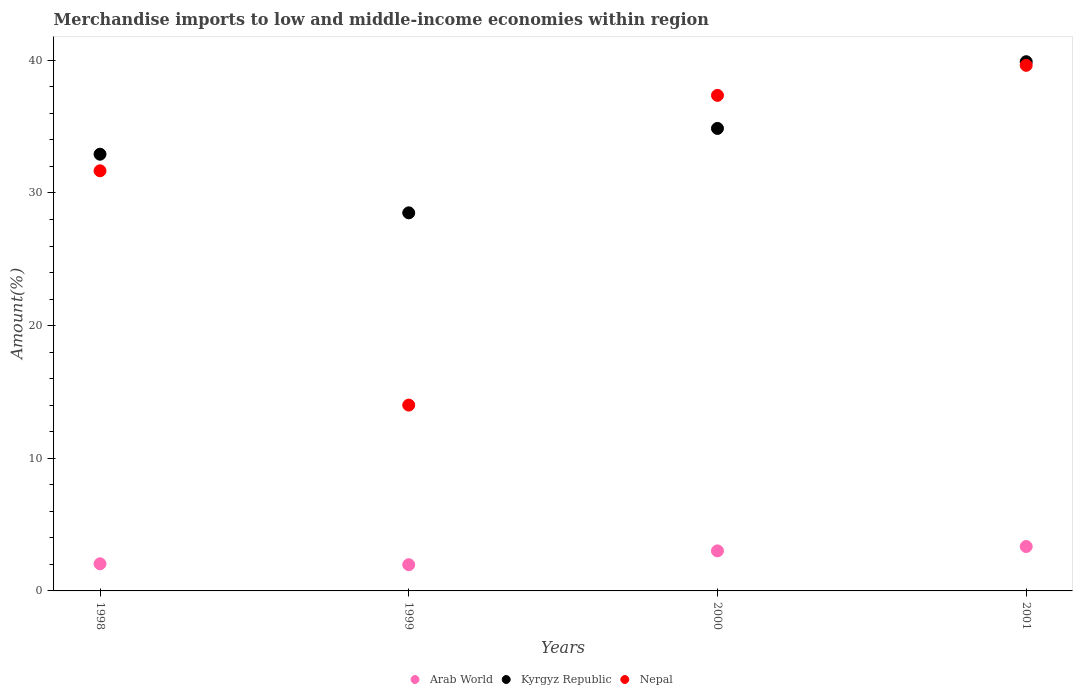How many different coloured dotlines are there?
Make the answer very short. 3. What is the percentage of amount earned from merchandise imports in Kyrgyz Republic in 2001?
Ensure brevity in your answer.  39.89. Across all years, what is the maximum percentage of amount earned from merchandise imports in Nepal?
Offer a terse response. 39.62. Across all years, what is the minimum percentage of amount earned from merchandise imports in Arab World?
Provide a short and direct response. 1.98. In which year was the percentage of amount earned from merchandise imports in Arab World maximum?
Make the answer very short. 2001. In which year was the percentage of amount earned from merchandise imports in Nepal minimum?
Ensure brevity in your answer.  1999. What is the total percentage of amount earned from merchandise imports in Arab World in the graph?
Your answer should be compact. 10.39. What is the difference between the percentage of amount earned from merchandise imports in Nepal in 1999 and that in 2001?
Give a very brief answer. -25.61. What is the difference between the percentage of amount earned from merchandise imports in Arab World in 1999 and the percentage of amount earned from merchandise imports in Kyrgyz Republic in 2000?
Your answer should be very brief. -32.89. What is the average percentage of amount earned from merchandise imports in Nepal per year?
Make the answer very short. 30.66. In the year 2000, what is the difference between the percentage of amount earned from merchandise imports in Kyrgyz Republic and percentage of amount earned from merchandise imports in Nepal?
Your answer should be very brief. -2.49. In how many years, is the percentage of amount earned from merchandise imports in Nepal greater than 2 %?
Your response must be concise. 4. What is the ratio of the percentage of amount earned from merchandise imports in Nepal in 1998 to that in 2001?
Keep it short and to the point. 0.8. What is the difference between the highest and the second highest percentage of amount earned from merchandise imports in Arab World?
Give a very brief answer. 0.33. What is the difference between the highest and the lowest percentage of amount earned from merchandise imports in Arab World?
Your response must be concise. 1.37. Is the sum of the percentage of amount earned from merchandise imports in Arab World in 1999 and 2000 greater than the maximum percentage of amount earned from merchandise imports in Kyrgyz Republic across all years?
Give a very brief answer. No. Does the percentage of amount earned from merchandise imports in Arab World monotonically increase over the years?
Provide a succinct answer. No. Is the percentage of amount earned from merchandise imports in Kyrgyz Republic strictly less than the percentage of amount earned from merchandise imports in Arab World over the years?
Your response must be concise. No. What is the difference between two consecutive major ticks on the Y-axis?
Keep it short and to the point. 10. Does the graph contain any zero values?
Ensure brevity in your answer.  No. Does the graph contain grids?
Make the answer very short. No. Where does the legend appear in the graph?
Offer a terse response. Bottom center. How are the legend labels stacked?
Offer a terse response. Horizontal. What is the title of the graph?
Make the answer very short. Merchandise imports to low and middle-income economies within region. Does "Latin America(all income levels)" appear as one of the legend labels in the graph?
Your response must be concise. No. What is the label or title of the Y-axis?
Keep it short and to the point. Amount(%). What is the Amount(%) of Arab World in 1998?
Keep it short and to the point. 2.05. What is the Amount(%) of Kyrgyz Republic in 1998?
Provide a succinct answer. 32.92. What is the Amount(%) of Nepal in 1998?
Your answer should be very brief. 31.67. What is the Amount(%) in Arab World in 1999?
Your answer should be very brief. 1.98. What is the Amount(%) in Kyrgyz Republic in 1999?
Provide a succinct answer. 28.5. What is the Amount(%) of Nepal in 1999?
Your answer should be compact. 14.01. What is the Amount(%) of Arab World in 2000?
Give a very brief answer. 3.02. What is the Amount(%) of Kyrgyz Republic in 2000?
Keep it short and to the point. 34.86. What is the Amount(%) in Nepal in 2000?
Give a very brief answer. 37.36. What is the Amount(%) in Arab World in 2001?
Your response must be concise. 3.35. What is the Amount(%) in Kyrgyz Republic in 2001?
Your answer should be very brief. 39.89. What is the Amount(%) in Nepal in 2001?
Offer a terse response. 39.62. Across all years, what is the maximum Amount(%) in Arab World?
Your response must be concise. 3.35. Across all years, what is the maximum Amount(%) in Kyrgyz Republic?
Make the answer very short. 39.89. Across all years, what is the maximum Amount(%) in Nepal?
Give a very brief answer. 39.62. Across all years, what is the minimum Amount(%) of Arab World?
Your answer should be very brief. 1.98. Across all years, what is the minimum Amount(%) in Kyrgyz Republic?
Your answer should be compact. 28.5. Across all years, what is the minimum Amount(%) of Nepal?
Ensure brevity in your answer.  14.01. What is the total Amount(%) of Arab World in the graph?
Your response must be concise. 10.39. What is the total Amount(%) in Kyrgyz Republic in the graph?
Provide a succinct answer. 136.18. What is the total Amount(%) of Nepal in the graph?
Provide a succinct answer. 122.66. What is the difference between the Amount(%) of Arab World in 1998 and that in 1999?
Your response must be concise. 0.07. What is the difference between the Amount(%) of Kyrgyz Republic in 1998 and that in 1999?
Offer a terse response. 4.42. What is the difference between the Amount(%) in Nepal in 1998 and that in 1999?
Your answer should be compact. 17.66. What is the difference between the Amount(%) of Arab World in 1998 and that in 2000?
Keep it short and to the point. -0.97. What is the difference between the Amount(%) of Kyrgyz Republic in 1998 and that in 2000?
Your response must be concise. -1.94. What is the difference between the Amount(%) in Nepal in 1998 and that in 2000?
Keep it short and to the point. -5.69. What is the difference between the Amount(%) in Arab World in 1998 and that in 2001?
Keep it short and to the point. -1.3. What is the difference between the Amount(%) of Kyrgyz Republic in 1998 and that in 2001?
Your answer should be very brief. -6.97. What is the difference between the Amount(%) of Nepal in 1998 and that in 2001?
Make the answer very short. -7.95. What is the difference between the Amount(%) of Arab World in 1999 and that in 2000?
Keep it short and to the point. -1.04. What is the difference between the Amount(%) of Kyrgyz Republic in 1999 and that in 2000?
Provide a succinct answer. -6.36. What is the difference between the Amount(%) of Nepal in 1999 and that in 2000?
Offer a terse response. -23.35. What is the difference between the Amount(%) in Arab World in 1999 and that in 2001?
Give a very brief answer. -1.37. What is the difference between the Amount(%) of Kyrgyz Republic in 1999 and that in 2001?
Make the answer very short. -11.39. What is the difference between the Amount(%) of Nepal in 1999 and that in 2001?
Give a very brief answer. -25.61. What is the difference between the Amount(%) in Arab World in 2000 and that in 2001?
Ensure brevity in your answer.  -0.33. What is the difference between the Amount(%) of Kyrgyz Republic in 2000 and that in 2001?
Keep it short and to the point. -5.03. What is the difference between the Amount(%) of Nepal in 2000 and that in 2001?
Ensure brevity in your answer.  -2.27. What is the difference between the Amount(%) of Arab World in 1998 and the Amount(%) of Kyrgyz Republic in 1999?
Your response must be concise. -26.46. What is the difference between the Amount(%) in Arab World in 1998 and the Amount(%) in Nepal in 1999?
Your answer should be compact. -11.96. What is the difference between the Amount(%) in Kyrgyz Republic in 1998 and the Amount(%) in Nepal in 1999?
Offer a terse response. 18.91. What is the difference between the Amount(%) of Arab World in 1998 and the Amount(%) of Kyrgyz Republic in 2000?
Make the answer very short. -32.82. What is the difference between the Amount(%) of Arab World in 1998 and the Amount(%) of Nepal in 2000?
Offer a terse response. -35.31. What is the difference between the Amount(%) in Kyrgyz Republic in 1998 and the Amount(%) in Nepal in 2000?
Your answer should be very brief. -4.43. What is the difference between the Amount(%) in Arab World in 1998 and the Amount(%) in Kyrgyz Republic in 2001?
Your answer should be very brief. -37.85. What is the difference between the Amount(%) in Arab World in 1998 and the Amount(%) in Nepal in 2001?
Your answer should be compact. -37.58. What is the difference between the Amount(%) in Kyrgyz Republic in 1998 and the Amount(%) in Nepal in 2001?
Provide a succinct answer. -6.7. What is the difference between the Amount(%) of Arab World in 1999 and the Amount(%) of Kyrgyz Republic in 2000?
Your answer should be very brief. -32.89. What is the difference between the Amount(%) in Arab World in 1999 and the Amount(%) in Nepal in 2000?
Make the answer very short. -35.38. What is the difference between the Amount(%) in Kyrgyz Republic in 1999 and the Amount(%) in Nepal in 2000?
Provide a short and direct response. -8.85. What is the difference between the Amount(%) in Arab World in 1999 and the Amount(%) in Kyrgyz Republic in 2001?
Give a very brief answer. -37.92. What is the difference between the Amount(%) of Arab World in 1999 and the Amount(%) of Nepal in 2001?
Offer a terse response. -37.64. What is the difference between the Amount(%) of Kyrgyz Republic in 1999 and the Amount(%) of Nepal in 2001?
Give a very brief answer. -11.12. What is the difference between the Amount(%) of Arab World in 2000 and the Amount(%) of Kyrgyz Republic in 2001?
Ensure brevity in your answer.  -36.88. What is the difference between the Amount(%) in Arab World in 2000 and the Amount(%) in Nepal in 2001?
Your answer should be very brief. -36.6. What is the difference between the Amount(%) of Kyrgyz Republic in 2000 and the Amount(%) of Nepal in 2001?
Provide a succinct answer. -4.76. What is the average Amount(%) in Arab World per year?
Your answer should be very brief. 2.6. What is the average Amount(%) of Kyrgyz Republic per year?
Make the answer very short. 34.04. What is the average Amount(%) in Nepal per year?
Offer a very short reply. 30.66. In the year 1998, what is the difference between the Amount(%) in Arab World and Amount(%) in Kyrgyz Republic?
Keep it short and to the point. -30.88. In the year 1998, what is the difference between the Amount(%) in Arab World and Amount(%) in Nepal?
Offer a terse response. -29.63. In the year 1998, what is the difference between the Amount(%) in Kyrgyz Republic and Amount(%) in Nepal?
Provide a succinct answer. 1.25. In the year 1999, what is the difference between the Amount(%) of Arab World and Amount(%) of Kyrgyz Republic?
Your answer should be compact. -26.52. In the year 1999, what is the difference between the Amount(%) of Arab World and Amount(%) of Nepal?
Ensure brevity in your answer.  -12.03. In the year 1999, what is the difference between the Amount(%) in Kyrgyz Republic and Amount(%) in Nepal?
Keep it short and to the point. 14.49. In the year 2000, what is the difference between the Amount(%) in Arab World and Amount(%) in Kyrgyz Republic?
Provide a succinct answer. -31.85. In the year 2000, what is the difference between the Amount(%) in Arab World and Amount(%) in Nepal?
Keep it short and to the point. -34.34. In the year 2000, what is the difference between the Amount(%) in Kyrgyz Republic and Amount(%) in Nepal?
Offer a very short reply. -2.49. In the year 2001, what is the difference between the Amount(%) of Arab World and Amount(%) of Kyrgyz Republic?
Provide a succinct answer. -36.55. In the year 2001, what is the difference between the Amount(%) of Arab World and Amount(%) of Nepal?
Make the answer very short. -36.27. In the year 2001, what is the difference between the Amount(%) of Kyrgyz Republic and Amount(%) of Nepal?
Provide a succinct answer. 0.27. What is the ratio of the Amount(%) of Arab World in 1998 to that in 1999?
Ensure brevity in your answer.  1.03. What is the ratio of the Amount(%) of Kyrgyz Republic in 1998 to that in 1999?
Make the answer very short. 1.16. What is the ratio of the Amount(%) in Nepal in 1998 to that in 1999?
Your answer should be very brief. 2.26. What is the ratio of the Amount(%) in Arab World in 1998 to that in 2000?
Provide a short and direct response. 0.68. What is the ratio of the Amount(%) in Kyrgyz Republic in 1998 to that in 2000?
Your response must be concise. 0.94. What is the ratio of the Amount(%) of Nepal in 1998 to that in 2000?
Keep it short and to the point. 0.85. What is the ratio of the Amount(%) of Arab World in 1998 to that in 2001?
Offer a terse response. 0.61. What is the ratio of the Amount(%) of Kyrgyz Republic in 1998 to that in 2001?
Provide a short and direct response. 0.83. What is the ratio of the Amount(%) in Nepal in 1998 to that in 2001?
Your answer should be very brief. 0.8. What is the ratio of the Amount(%) in Arab World in 1999 to that in 2000?
Your response must be concise. 0.66. What is the ratio of the Amount(%) in Kyrgyz Republic in 1999 to that in 2000?
Your answer should be very brief. 0.82. What is the ratio of the Amount(%) of Arab World in 1999 to that in 2001?
Your answer should be compact. 0.59. What is the ratio of the Amount(%) of Kyrgyz Republic in 1999 to that in 2001?
Your answer should be compact. 0.71. What is the ratio of the Amount(%) of Nepal in 1999 to that in 2001?
Give a very brief answer. 0.35. What is the ratio of the Amount(%) in Arab World in 2000 to that in 2001?
Your answer should be compact. 0.9. What is the ratio of the Amount(%) in Kyrgyz Republic in 2000 to that in 2001?
Your answer should be very brief. 0.87. What is the ratio of the Amount(%) in Nepal in 2000 to that in 2001?
Give a very brief answer. 0.94. What is the difference between the highest and the second highest Amount(%) in Arab World?
Your answer should be compact. 0.33. What is the difference between the highest and the second highest Amount(%) in Kyrgyz Republic?
Keep it short and to the point. 5.03. What is the difference between the highest and the second highest Amount(%) of Nepal?
Your response must be concise. 2.27. What is the difference between the highest and the lowest Amount(%) in Arab World?
Your response must be concise. 1.37. What is the difference between the highest and the lowest Amount(%) in Kyrgyz Republic?
Provide a succinct answer. 11.39. What is the difference between the highest and the lowest Amount(%) of Nepal?
Ensure brevity in your answer.  25.61. 